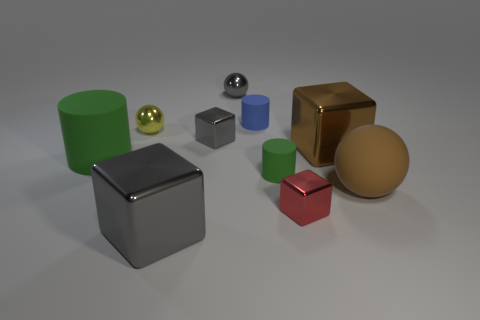Subtract all cylinders. How many objects are left? 7 Add 8 green things. How many green things exist? 10 Subtract 0 brown cylinders. How many objects are left? 10 Subtract all brown blocks. Subtract all tiny red metallic cubes. How many objects are left? 8 Add 4 yellow shiny spheres. How many yellow shiny spheres are left? 5 